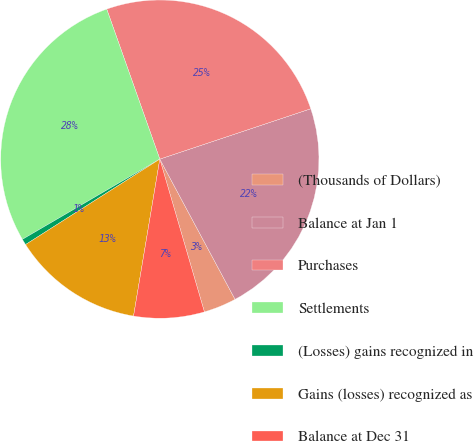Convert chart. <chart><loc_0><loc_0><loc_500><loc_500><pie_chart><fcel>(Thousands of Dollars)<fcel>Balance at Jan 1<fcel>Purchases<fcel>Settlements<fcel>(Losses) gains recognized in<fcel>Gains (losses) recognized as<fcel>Balance at Dec 31<nl><fcel>3.32%<fcel>22.29%<fcel>25.29%<fcel>28.0%<fcel>0.61%<fcel>13.34%<fcel>7.16%<nl></chart> 